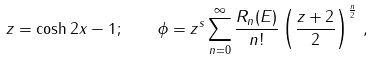Convert formula to latex. <formula><loc_0><loc_0><loc_500><loc_500>z = \cosh 2 x - 1 ; \quad \phi = z ^ { s } \sum _ { n = 0 } ^ { \infty } \frac { R _ { n } ( E ) } { n ! } \left ( \frac { z + 2 } { 2 } \right ) ^ { \frac { n } { 2 } } \, ,</formula> 